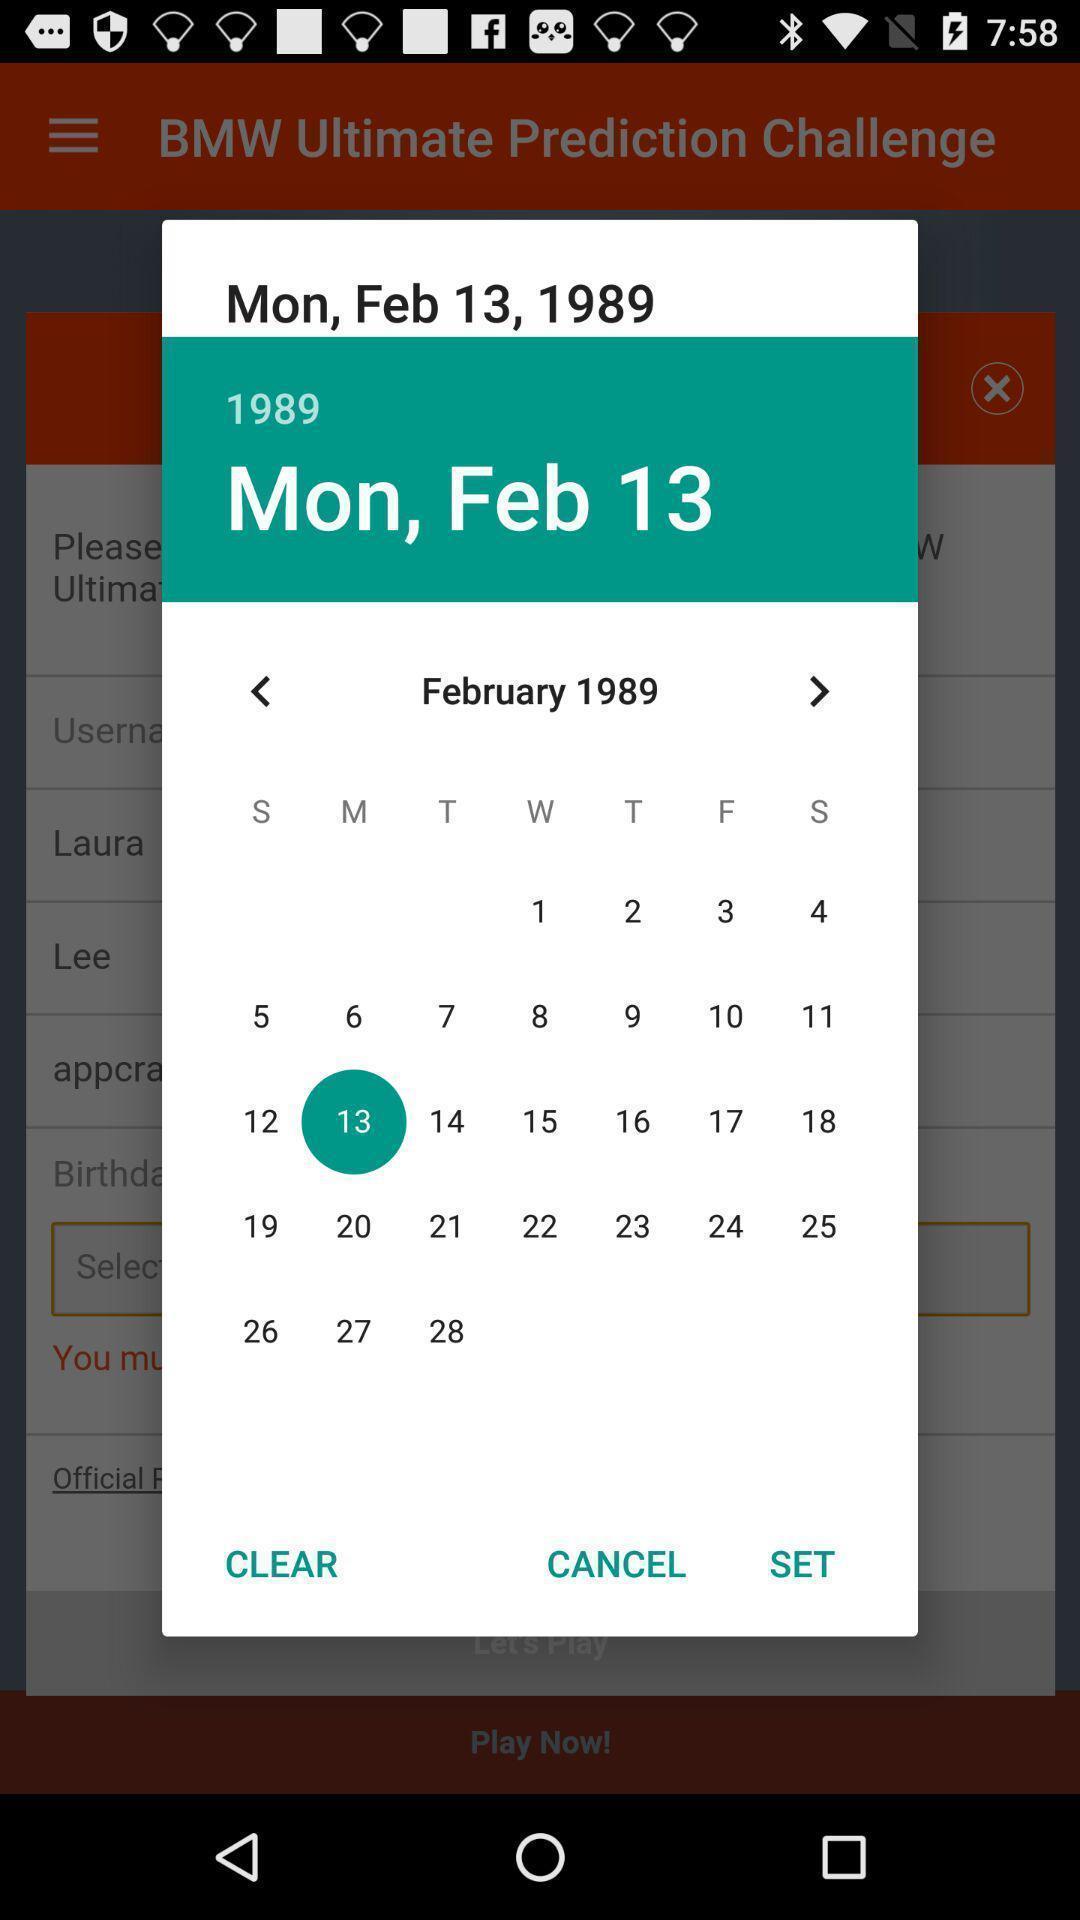Give me a summary of this screen capture. Pop-up to select a date on a calendar. 